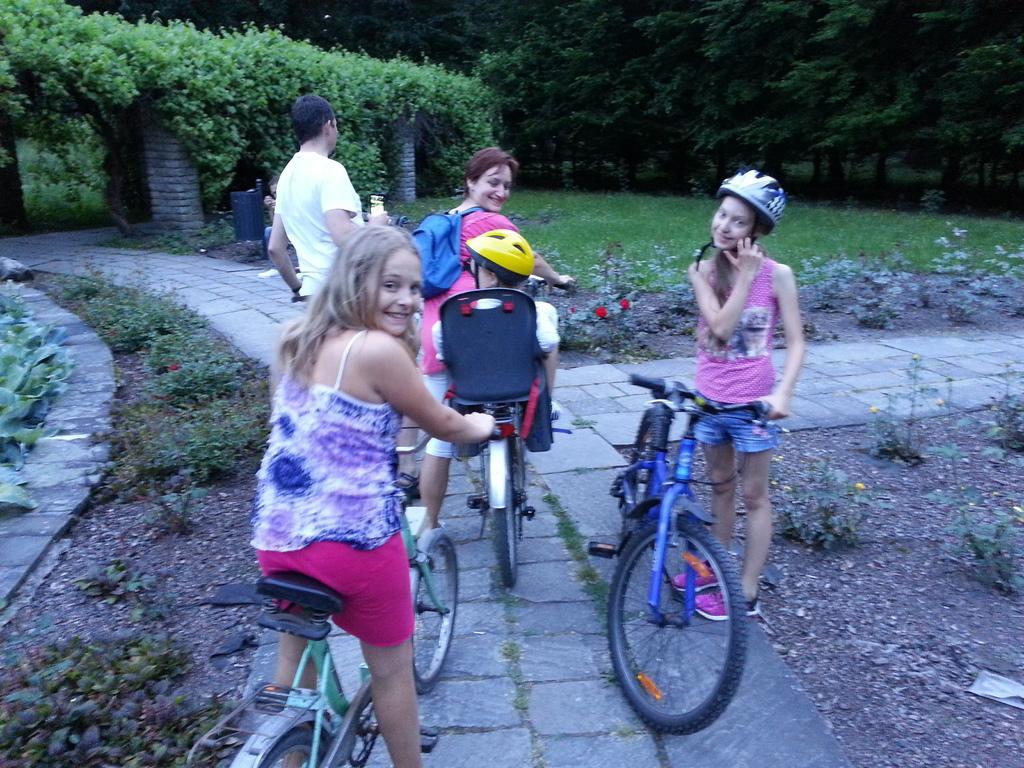How would you summarize this image in a sentence or two? In the picture there are few kids sat on bicycles on a path. on either sides there is garden and plants. 